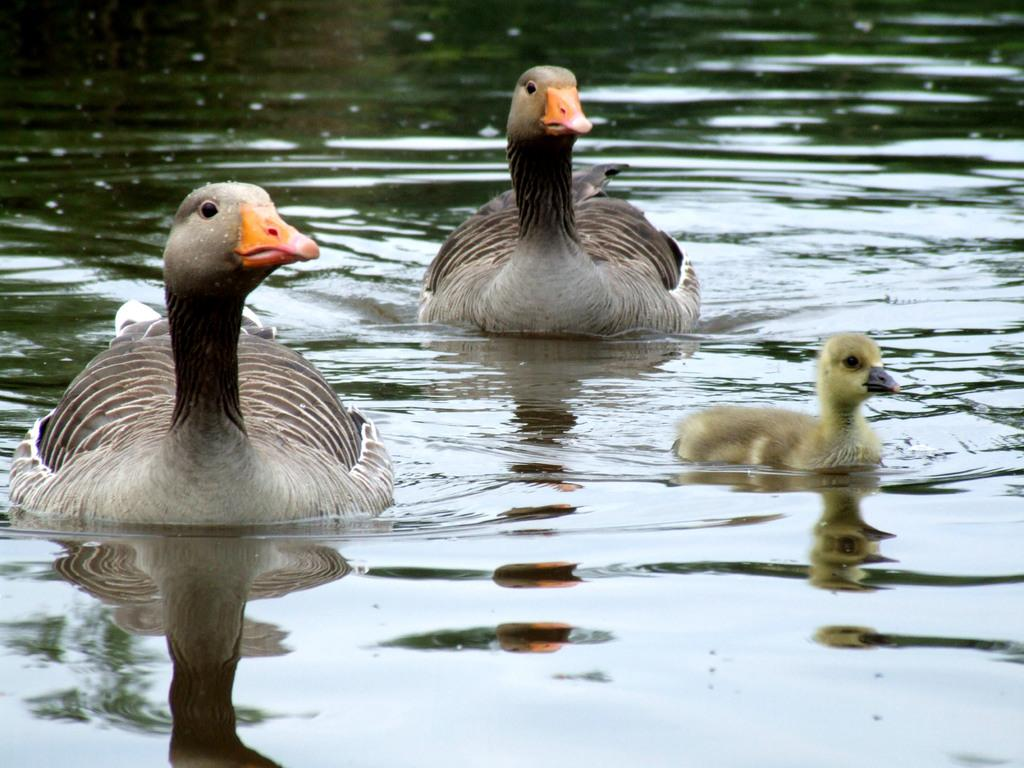What type of animals are in the image? There are ducks in the image. Where are the ducks located? The ducks are in the water. What is visible in the image besides the ducks? Water is visible in the image. What time of day is it in the image, specifically in the afternoon? The time of day is not mentioned or depicted in the image, so it cannot be determined whether it is afternoon or not. 